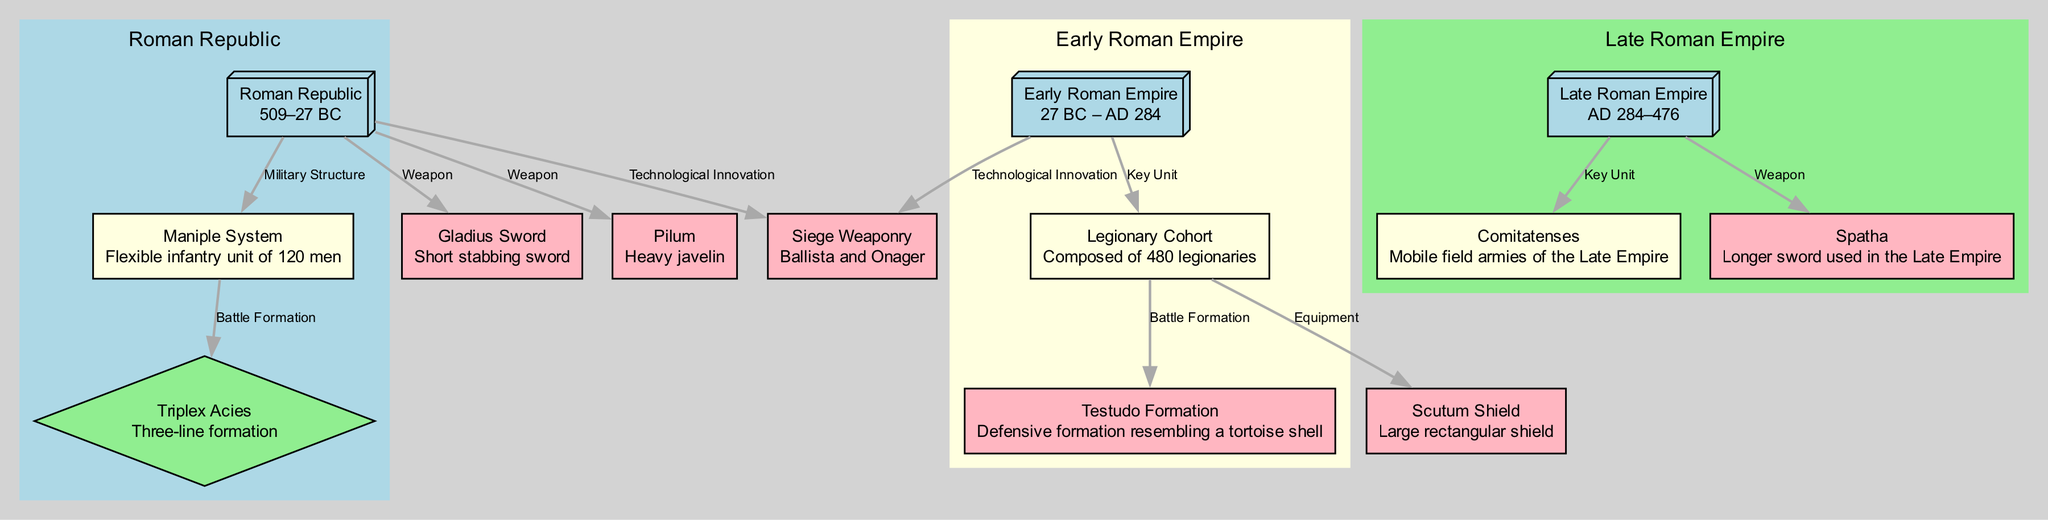What time period does the Roman Republic cover? The label of the "Roman Republic" node states that it covers the time period from 509–27 BC. This information is directly found in the description provided for that node.
Answer: 509–27 BC What military structure is associated with the Roman Republic? The edge labeled "Military Structure" connects the "Roman Republic" node to the "Maniple System" node. Thus, the Maniple System is the military structure associated with the Roman Republic.
Answer: Maniple System How many nodes represent the Late Roman Empire? The diagram clearly lists three nodes related to the Late Roman Empire: "Late Roman Empire," "Comitatenses," and "Spatha." By counting these nodes, we find there are three.
Answer: 3 What formation is related to the Legionary Cohort? The edge labeled "Battle Formation" connects the "Legionary Cohort" node to the "Testudo" node, indicating that the Testudo Formation is related to the Legionary Cohort.
Answer: Testudo Formation What weapon was introduced in the Roman Republic for soldiers? The edges labeled "Weapon" connect the "Roman Republic" node to both "Gladius" and "Pilum." Therefore, either of these weapons can be considered as introduced in that period.
Answer: Gladius or Pilum Which key unit was present during the Early Roman Empire? The "Key Unit" edge connects the "Early Roman Empire" node to the "Legionary Cohort" node. This indicates that the Legionary Cohort was the key unit during the Early Roman Empire.
Answer: Legionary Cohort What military formation does the Maniple System relate to? The "Battle Formation" edge connects the "Maniple System" node to the "Triplex Acies" node, showing that the Triplex Acies formation relates to the Maniple System.
Answer: Triplex Acies What weapon innovations were utilized in both the Roman Republic and the Early Roman Empire? The "Technological Innovation" edge leads from both the "Roman Republic" and "Early Roman Empire" nodes to the "Siege Weaponry" node, indicating that Siege Weaponry was used in both periods.
Answer: Siege Weaponry 